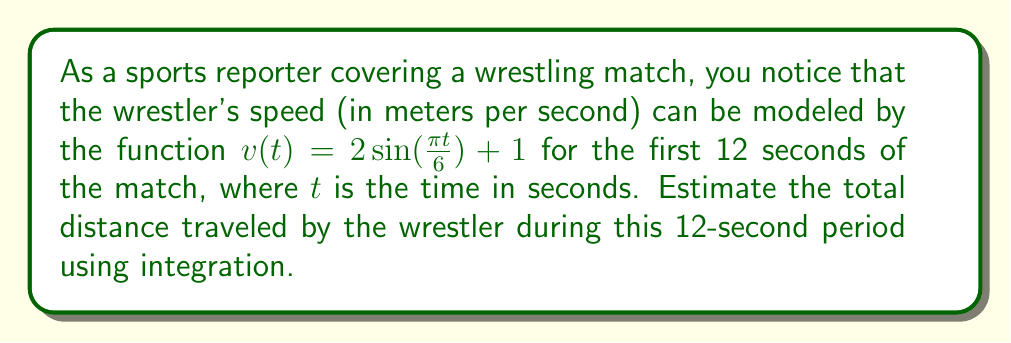Teach me how to tackle this problem. To solve this problem, we need to integrate the velocity function over the given time interval. The steps are as follows:

1) The distance traveled is given by the integral of velocity with respect to time:

   $$d = \int_0^{12} v(t) dt$$

2) Substituting our velocity function:

   $$d = \int_0^{12} (2\sin(\frac{\pi t}{6}) + 1) dt$$

3) We can split this into two integrals:

   $$d = \int_0^{12} 2\sin(\frac{\pi t}{6}) dt + \int_0^{12} 1 dt$$

4) For the first integral, we can use the substitution $u = \frac{\pi t}{6}$, so $du = \frac{\pi}{6} dt$ or $dt = \frac{6}{\pi} du$:

   $$\int_0^{12} 2\sin(\frac{\pi t}{6}) dt = \frac{12}{\pi} \int_0^{2\pi} \sin(u) du = \frac{12}{\pi} [-\cos(u)]_0^{2\pi} = \frac{12}{\pi} [(-\cos(2\pi)) - (-\cos(0))] = 0$$

5) The second integral is straightforward:

   $$\int_0^{12} 1 dt = [t]_0^{12} = 12 - 0 = 12$$

6) Adding the results from steps 4 and 5:

   $$d = 0 + 12 = 12$$

Therefore, the wrestler travels approximately 12 meters during the first 12 seconds of the match.
Answer: 12 meters 